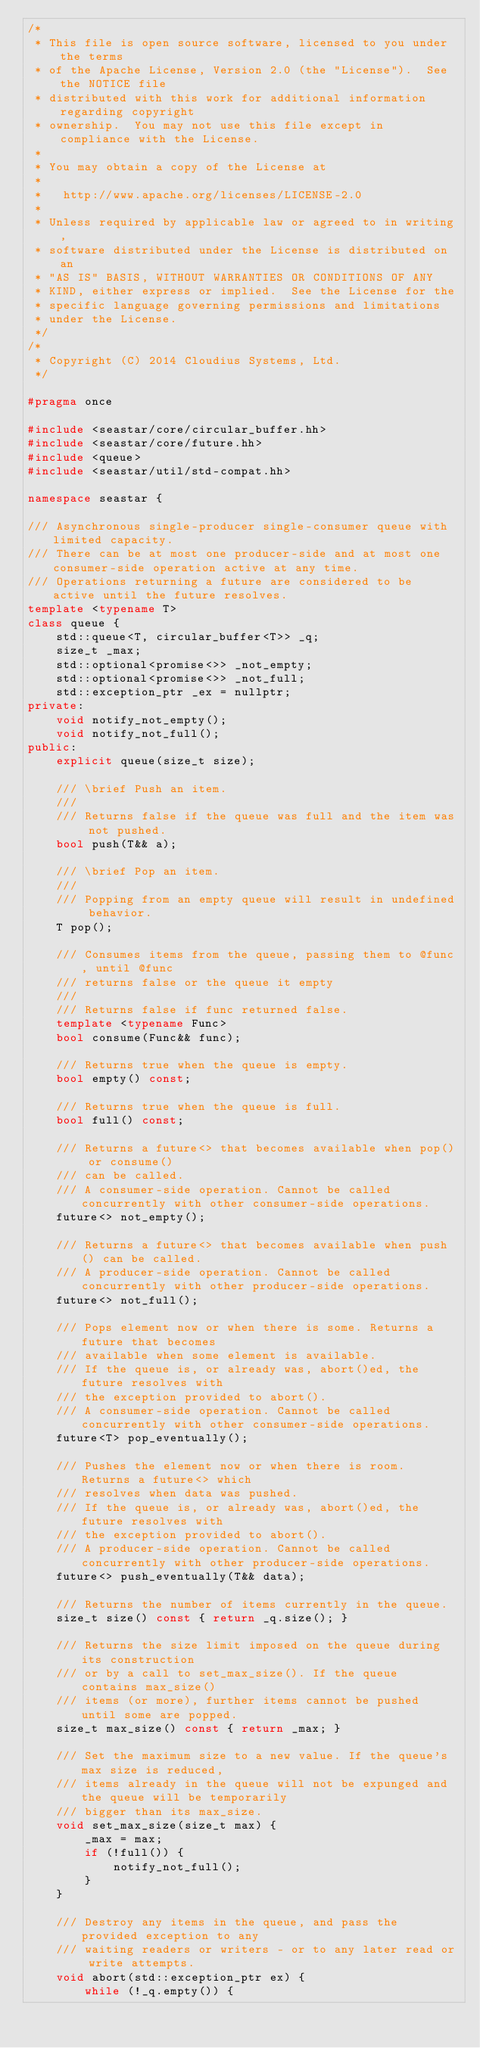<code> <loc_0><loc_0><loc_500><loc_500><_C++_>/*
 * This file is open source software, licensed to you under the terms
 * of the Apache License, Version 2.0 (the "License").  See the NOTICE file
 * distributed with this work for additional information regarding copyright
 * ownership.  You may not use this file except in compliance with the License.
 *
 * You may obtain a copy of the License at
 *
 *   http://www.apache.org/licenses/LICENSE-2.0
 *
 * Unless required by applicable law or agreed to in writing,
 * software distributed under the License is distributed on an
 * "AS IS" BASIS, WITHOUT WARRANTIES OR CONDITIONS OF ANY
 * KIND, either express or implied.  See the License for the
 * specific language governing permissions and limitations
 * under the License.
 */
/*
 * Copyright (C) 2014 Cloudius Systems, Ltd.
 */

#pragma once

#include <seastar/core/circular_buffer.hh>
#include <seastar/core/future.hh>
#include <queue>
#include <seastar/util/std-compat.hh>

namespace seastar {

/// Asynchronous single-producer single-consumer queue with limited capacity.
/// There can be at most one producer-side and at most one consumer-side operation active at any time.
/// Operations returning a future are considered to be active until the future resolves.
template <typename T>
class queue {
    std::queue<T, circular_buffer<T>> _q;
    size_t _max;
    std::optional<promise<>> _not_empty;
    std::optional<promise<>> _not_full;
    std::exception_ptr _ex = nullptr;
private:
    void notify_not_empty();
    void notify_not_full();
public:
    explicit queue(size_t size);

    /// \brief Push an item.
    ///
    /// Returns false if the queue was full and the item was not pushed.
    bool push(T&& a);

    /// \brief Pop an item.
    ///
    /// Popping from an empty queue will result in undefined behavior.
    T pop();

    /// Consumes items from the queue, passing them to @func, until @func
    /// returns false or the queue it empty
    ///
    /// Returns false if func returned false.
    template <typename Func>
    bool consume(Func&& func);

    /// Returns true when the queue is empty.
    bool empty() const;

    /// Returns true when the queue is full.
    bool full() const;

    /// Returns a future<> that becomes available when pop() or consume()
    /// can be called.
    /// A consumer-side operation. Cannot be called concurrently with other consumer-side operations.
    future<> not_empty();

    /// Returns a future<> that becomes available when push() can be called.
    /// A producer-side operation. Cannot be called concurrently with other producer-side operations.
    future<> not_full();

    /// Pops element now or when there is some. Returns a future that becomes
    /// available when some element is available.
    /// If the queue is, or already was, abort()ed, the future resolves with
    /// the exception provided to abort().
    /// A consumer-side operation. Cannot be called concurrently with other consumer-side operations.
    future<T> pop_eventually();

    /// Pushes the element now or when there is room. Returns a future<> which
    /// resolves when data was pushed.
    /// If the queue is, or already was, abort()ed, the future resolves with
    /// the exception provided to abort().
    /// A producer-side operation. Cannot be called concurrently with other producer-side operations.
    future<> push_eventually(T&& data);

    /// Returns the number of items currently in the queue.
    size_t size() const { return _q.size(); }

    /// Returns the size limit imposed on the queue during its construction
    /// or by a call to set_max_size(). If the queue contains max_size()
    /// items (or more), further items cannot be pushed until some are popped.
    size_t max_size() const { return _max; }

    /// Set the maximum size to a new value. If the queue's max size is reduced,
    /// items already in the queue will not be expunged and the queue will be temporarily
    /// bigger than its max_size.
    void set_max_size(size_t max) {
        _max = max;
        if (!full()) {
            notify_not_full();
        }
    }

    /// Destroy any items in the queue, and pass the provided exception to any
    /// waiting readers or writers - or to any later read or write attempts.
    void abort(std::exception_ptr ex) {
        while (!_q.empty()) {</code> 